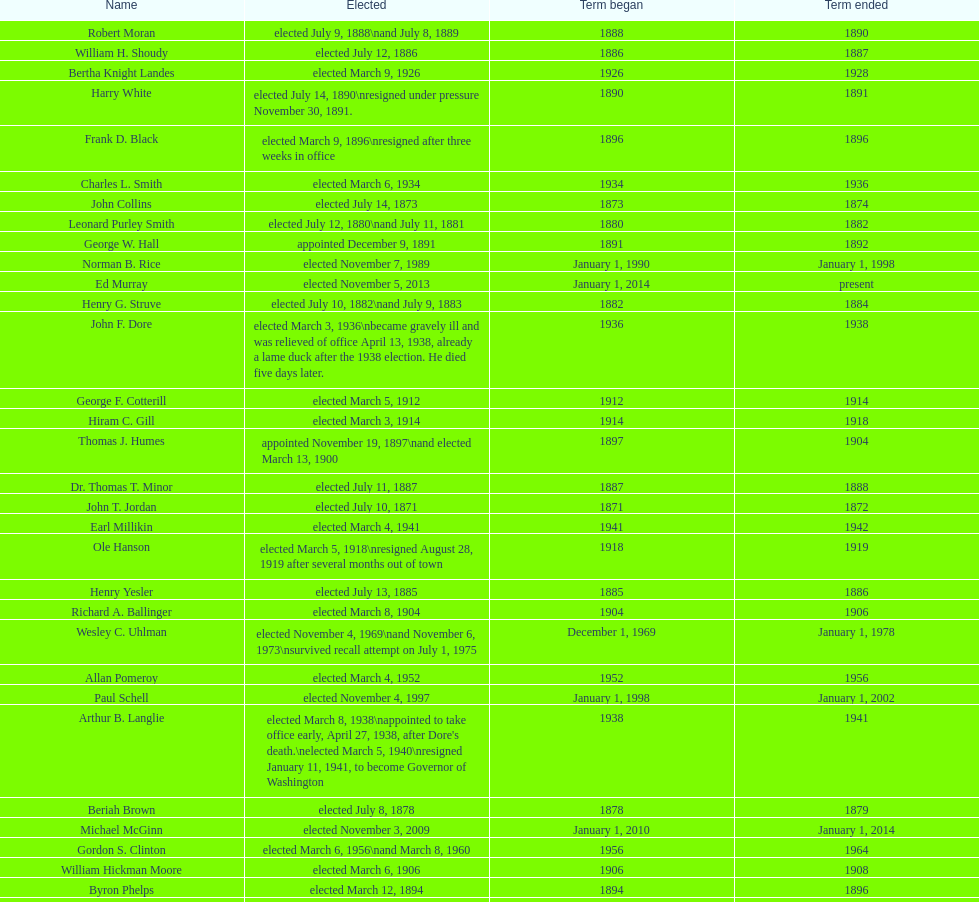Did charles royer hold office longer than paul schell? Yes. 